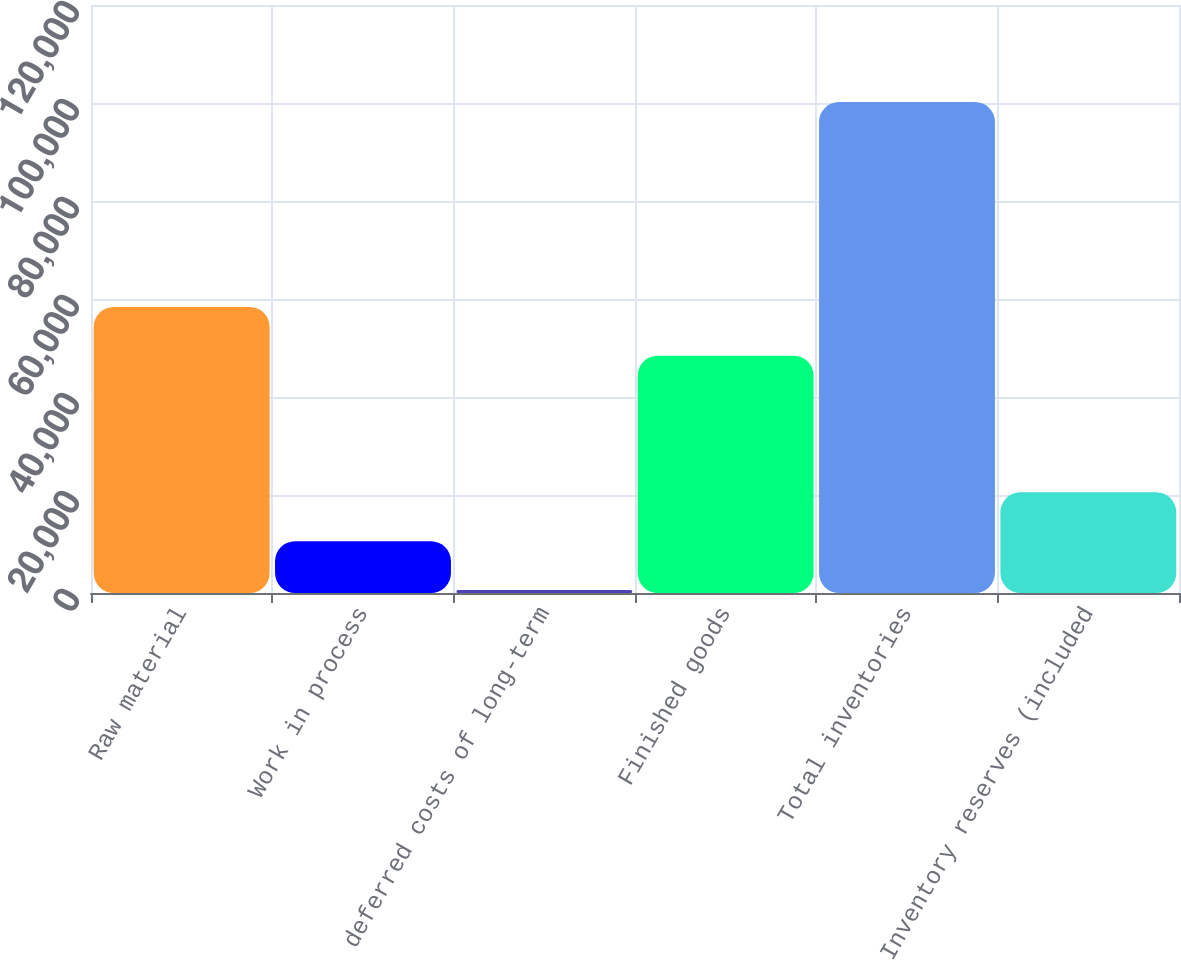Convert chart to OTSL. <chart><loc_0><loc_0><loc_500><loc_500><bar_chart><fcel>Raw material<fcel>Work in process<fcel>deferred costs of long-term<fcel>Finished goods<fcel>Total inventories<fcel>Inventory reserves (included<nl><fcel>58383.1<fcel>10585.1<fcel>628<fcel>48426<fcel>100199<fcel>20542.2<nl></chart> 